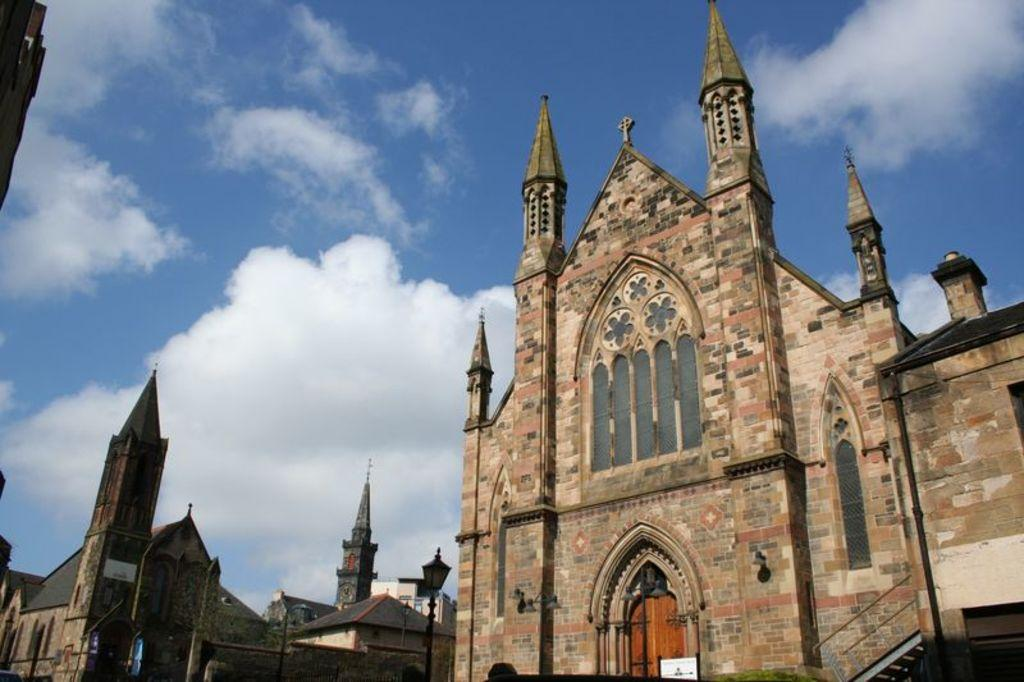What type of structures can be seen in the image? There are buildings in the image. What can be observed in the sky in the image? There are clouds in the sky in the image. What part of the brain can be seen in the image? There is no part of the brain present in the image; it features buildings and clouds. How does the throat appear in the image? There is no throat present in the image; it features buildings and clouds. 